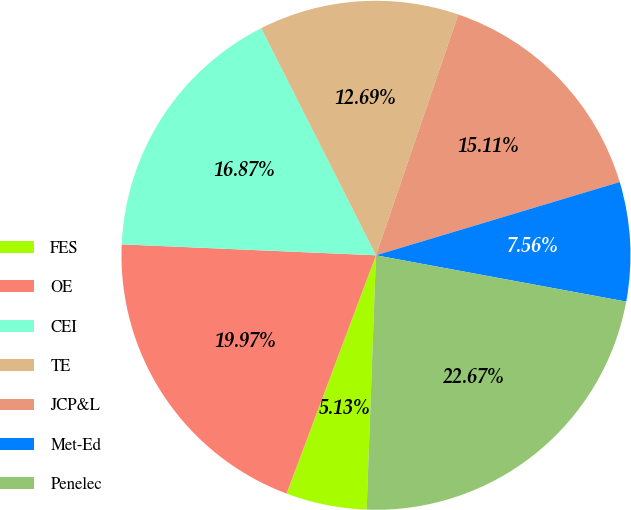Convert chart. <chart><loc_0><loc_0><loc_500><loc_500><pie_chart><fcel>FES<fcel>OE<fcel>CEI<fcel>TE<fcel>JCP&L<fcel>Met-Ed<fcel>Penelec<nl><fcel>5.13%<fcel>19.97%<fcel>16.87%<fcel>12.69%<fcel>15.11%<fcel>7.56%<fcel>22.67%<nl></chart> 